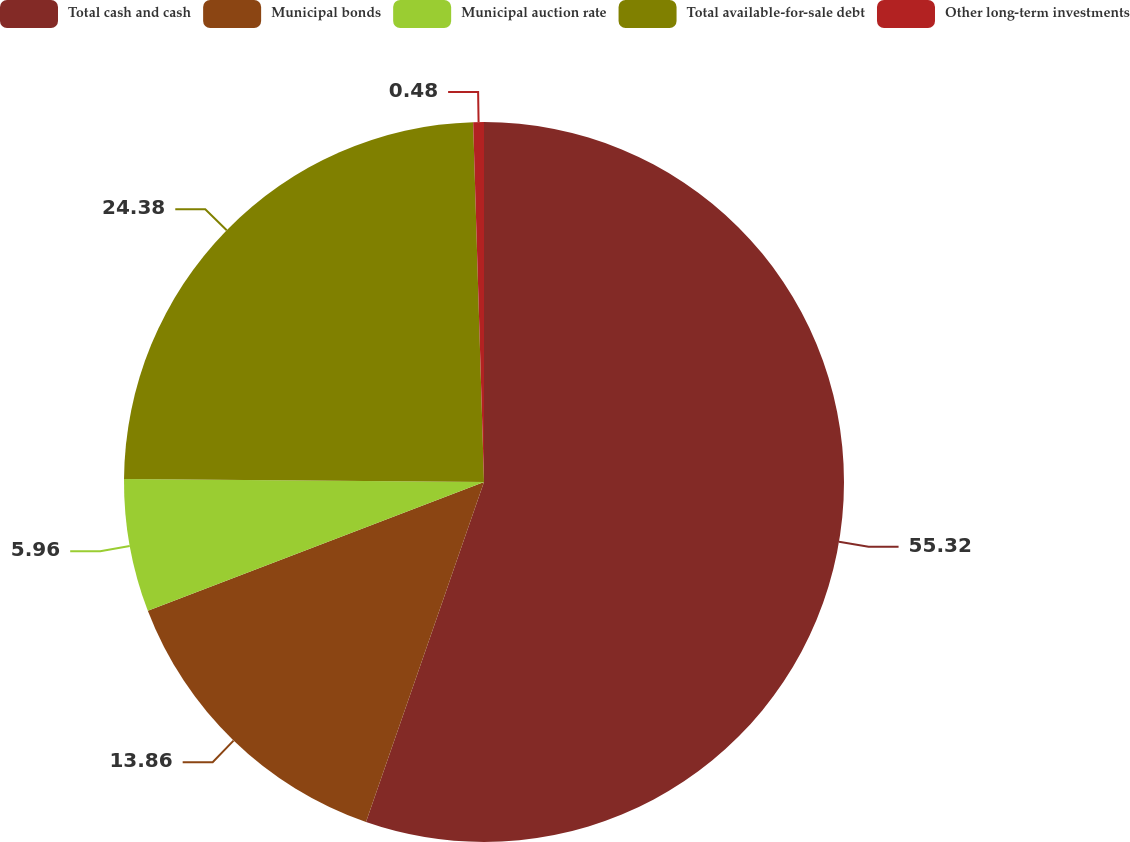Convert chart. <chart><loc_0><loc_0><loc_500><loc_500><pie_chart><fcel>Total cash and cash<fcel>Municipal bonds<fcel>Municipal auction rate<fcel>Total available-for-sale debt<fcel>Other long-term investments<nl><fcel>55.31%<fcel>13.86%<fcel>5.96%<fcel>24.38%<fcel>0.48%<nl></chart> 